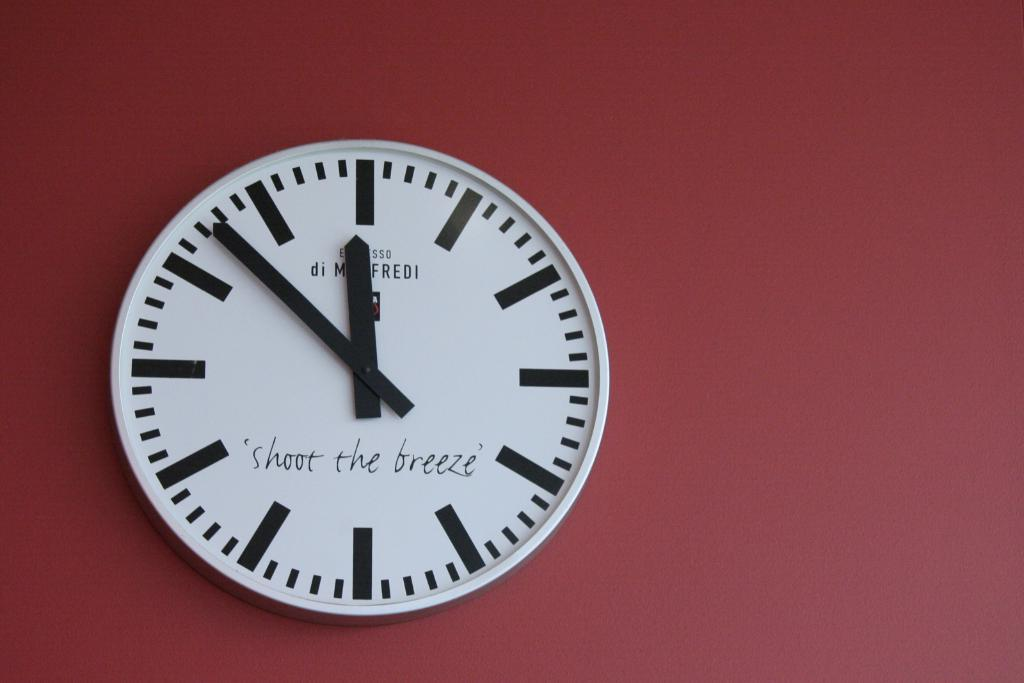<image>
Provide a brief description of the given image. A clock with the phrase "shoot the breeze" says that it is 11:53. 